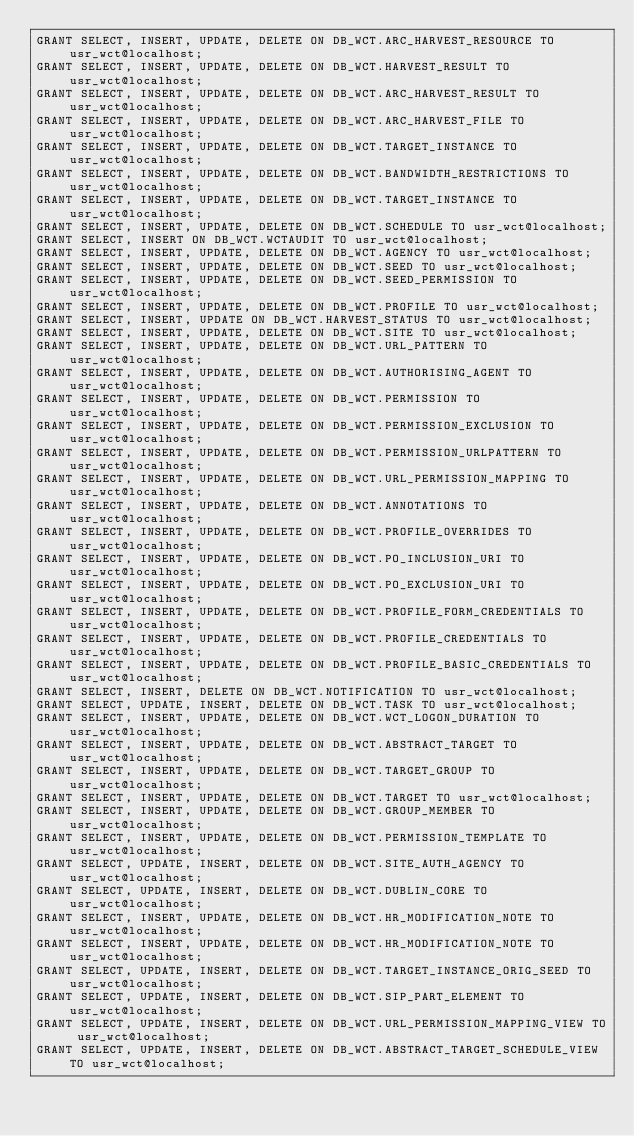<code> <loc_0><loc_0><loc_500><loc_500><_SQL_>GRANT SELECT, INSERT, UPDATE, DELETE ON DB_WCT.ARC_HARVEST_RESOURCE TO usr_wct@localhost;
GRANT SELECT, INSERT, UPDATE, DELETE ON DB_WCT.HARVEST_RESULT TO usr_wct@localhost;
GRANT SELECT, INSERT, UPDATE, DELETE ON DB_WCT.ARC_HARVEST_RESULT TO usr_wct@localhost;
GRANT SELECT, INSERT, UPDATE, DELETE ON DB_WCT.ARC_HARVEST_FILE TO usr_wct@localhost;
GRANT SELECT, INSERT, UPDATE, DELETE ON DB_WCT.TARGET_INSTANCE TO usr_wct@localhost;
GRANT SELECT, INSERT, UPDATE, DELETE ON DB_WCT.BANDWIDTH_RESTRICTIONS TO usr_wct@localhost;
GRANT SELECT, INSERT, UPDATE, DELETE ON DB_WCT.TARGET_INSTANCE TO usr_wct@localhost;
GRANT SELECT, INSERT, UPDATE, DELETE ON DB_WCT.SCHEDULE TO usr_wct@localhost;
GRANT SELECT, INSERT ON DB_WCT.WCTAUDIT TO usr_wct@localhost;
GRANT SELECT, INSERT, UPDATE, DELETE ON DB_WCT.AGENCY TO usr_wct@localhost;
GRANT SELECT, INSERT, UPDATE, DELETE ON DB_WCT.SEED TO usr_wct@localhost;
GRANT SELECT, INSERT, UPDATE, DELETE ON DB_WCT.SEED_PERMISSION TO usr_wct@localhost;
GRANT SELECT, INSERT, UPDATE, DELETE ON DB_WCT.PROFILE TO usr_wct@localhost;
GRANT SELECT, INSERT, UPDATE ON DB_WCT.HARVEST_STATUS TO usr_wct@localhost;
GRANT SELECT, INSERT, UPDATE, DELETE ON DB_WCT.SITE TO usr_wct@localhost;
GRANT SELECT, INSERT, UPDATE, DELETE ON DB_WCT.URL_PATTERN TO usr_wct@localhost;
GRANT SELECT, INSERT, UPDATE, DELETE ON DB_WCT.AUTHORISING_AGENT TO usr_wct@localhost;
GRANT SELECT, INSERT, UPDATE, DELETE ON DB_WCT.PERMISSION TO usr_wct@localhost;
GRANT SELECT, INSERT, UPDATE, DELETE ON DB_WCT.PERMISSION_EXCLUSION TO usr_wct@localhost;
GRANT SELECT, INSERT, UPDATE, DELETE ON DB_WCT.PERMISSION_URLPATTERN TO usr_wct@localhost;
GRANT SELECT, INSERT, UPDATE, DELETE ON DB_WCT.URL_PERMISSION_MAPPING TO usr_wct@localhost;
GRANT SELECT, INSERT, UPDATE, DELETE ON DB_WCT.ANNOTATIONS TO usr_wct@localhost;
GRANT SELECT, INSERT, UPDATE, DELETE ON DB_WCT.PROFILE_OVERRIDES TO usr_wct@localhost;
GRANT SELECT, INSERT, UPDATE, DELETE ON DB_WCT.PO_INCLUSION_URI TO usr_wct@localhost;
GRANT SELECT, INSERT, UPDATE, DELETE ON DB_WCT.PO_EXCLUSION_URI TO usr_wct@localhost;
GRANT SELECT, INSERT, UPDATE, DELETE ON DB_WCT.PROFILE_FORM_CREDENTIALS TO usr_wct@localhost;
GRANT SELECT, INSERT, UPDATE, DELETE ON DB_WCT.PROFILE_CREDENTIALS TO usr_wct@localhost;
GRANT SELECT, INSERT, UPDATE, DELETE ON DB_WCT.PROFILE_BASIC_CREDENTIALS TO usr_wct@localhost;
GRANT SELECT, INSERT, DELETE ON DB_WCT.NOTIFICATION TO usr_wct@localhost;
GRANT SELECT, UPDATE, INSERT, DELETE ON DB_WCT.TASK TO usr_wct@localhost;
GRANT SELECT, INSERT, UPDATE, DELETE ON DB_WCT.WCT_LOGON_DURATION TO usr_wct@localhost;
GRANT SELECT, INSERT, UPDATE, DELETE ON DB_WCT.ABSTRACT_TARGET TO usr_wct@localhost;
GRANT SELECT, INSERT, UPDATE, DELETE ON DB_WCT.TARGET_GROUP TO usr_wct@localhost;
GRANT SELECT, INSERT, UPDATE, DELETE ON DB_WCT.TARGET TO usr_wct@localhost;
GRANT SELECT, INSERT, UPDATE, DELETE ON DB_WCT.GROUP_MEMBER TO usr_wct@localhost;
GRANT SELECT, INSERT, UPDATE, DELETE ON DB_WCT.PERMISSION_TEMPLATE TO usr_wct@localhost;
GRANT SELECT, UPDATE, INSERT, DELETE ON DB_WCT.SITE_AUTH_AGENCY TO usr_wct@localhost;
GRANT SELECT, UPDATE, INSERT, DELETE ON DB_WCT.DUBLIN_CORE TO usr_wct@localhost;
GRANT SELECT, INSERT, UPDATE, DELETE ON DB_WCT.HR_MODIFICATION_NOTE TO usr_wct@localhost;
GRANT SELECT, INSERT, UPDATE, DELETE ON DB_WCT.HR_MODIFICATION_NOTE TO usr_wct@localhost;
GRANT SELECT, UPDATE, INSERT, DELETE ON DB_WCT.TARGET_INSTANCE_ORIG_SEED TO usr_wct@localhost;
GRANT SELECT, UPDATE, INSERT, DELETE ON DB_WCT.SIP_PART_ELEMENT TO usr_wct@localhost;
GRANT SELECT, UPDATE, INSERT, DELETE ON DB_WCT.URL_PERMISSION_MAPPING_VIEW TO usr_wct@localhost;
GRANT SELECT, UPDATE, INSERT, DELETE ON DB_WCT.ABSTRACT_TARGET_SCHEDULE_VIEW TO usr_wct@localhost;</code> 